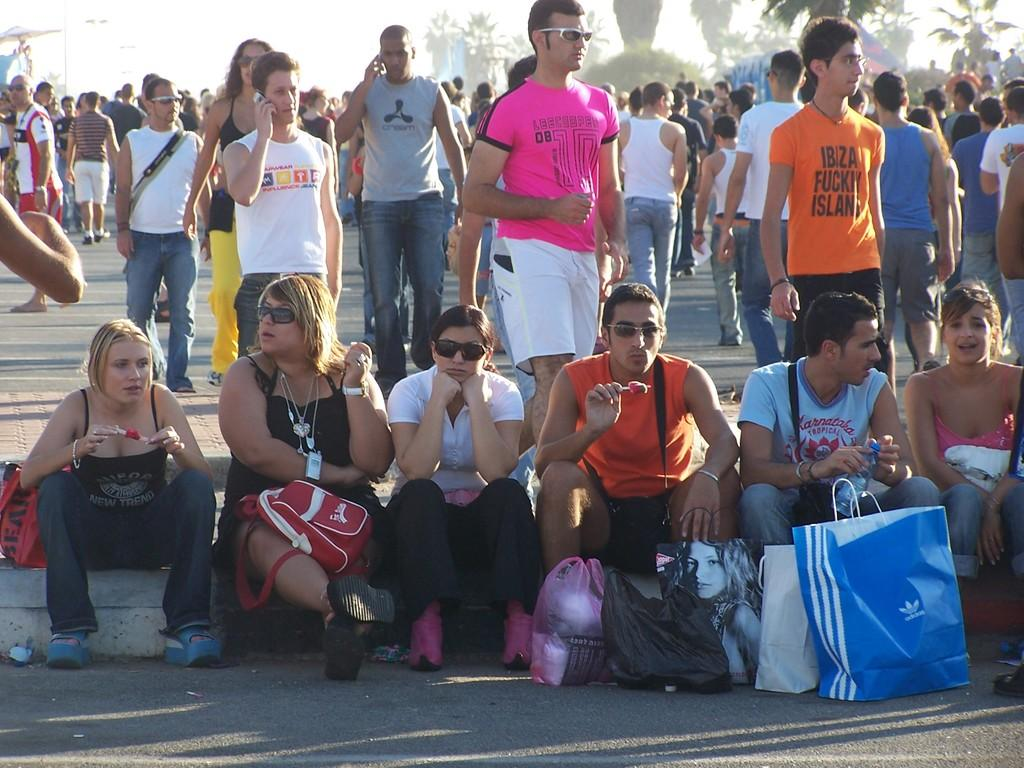<image>
Share a concise interpretation of the image provided. Adidas is branded onto the blue and white shopping bag sitting in the front of this group. 